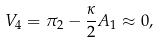<formula> <loc_0><loc_0><loc_500><loc_500>V _ { 4 } = \pi _ { 2 } - \frac { \kappa } { 2 } A _ { 1 } \approx 0 ,</formula> 